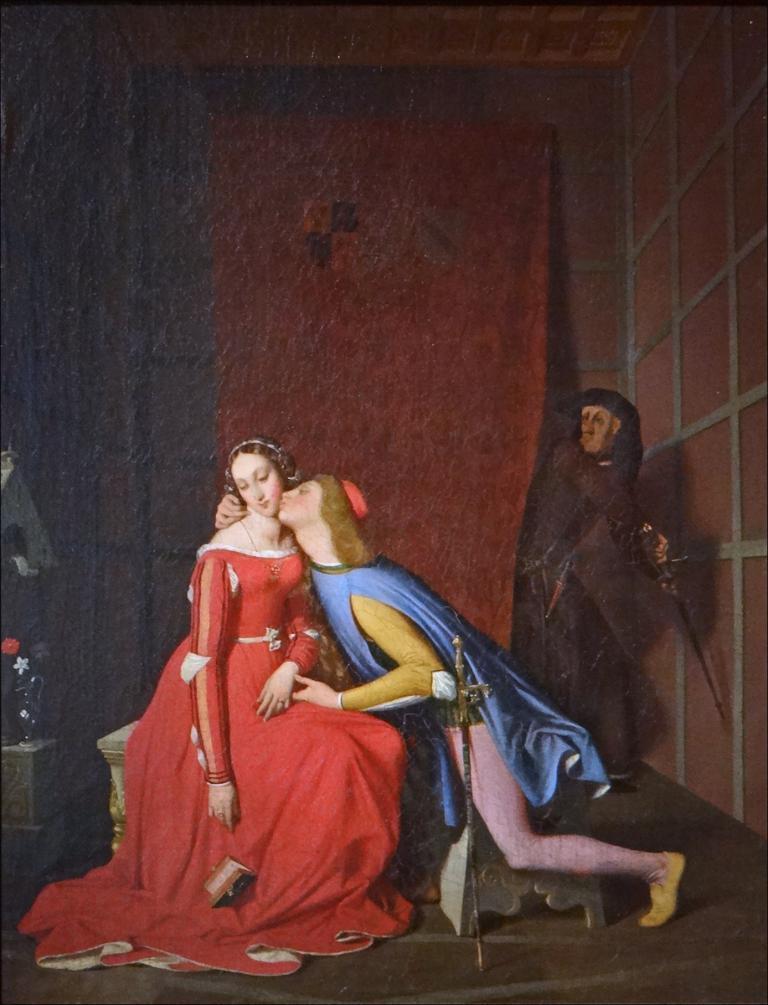Describe this image in one or two sentences. This image is taken indoors. In the background there is a wall. On the left side of the image there is an object. On the right side of the image there is a statue of a man holding a sword in the hand. In the middle of the image there is a statue of a woman sitting on the table and there is a statue of a man kissing a woman. 